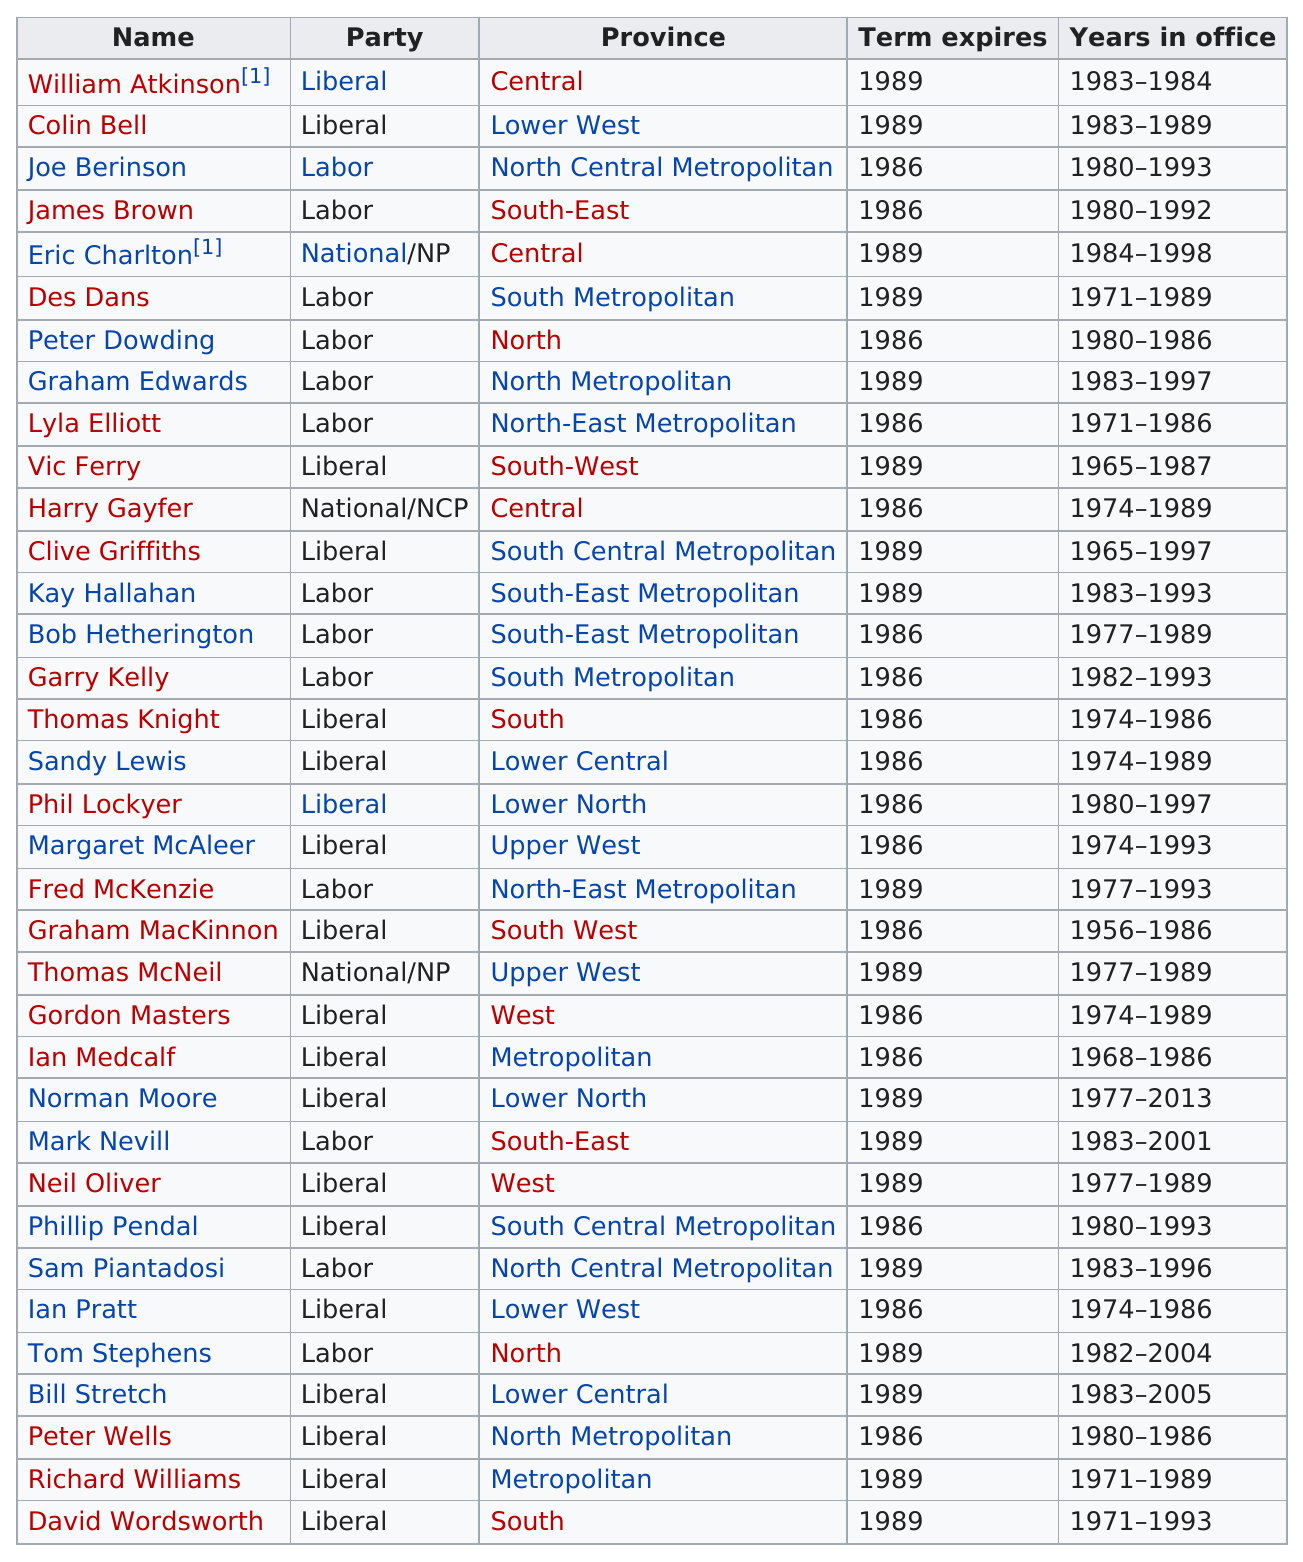Draw attention to some important aspects in this diagram. I have located the last member listed in the database whose last name starts with the letter 'p', which is Ian Pratt. There are 19 individuals in the Liberal Party. The Liberal party has the most membership. Phil Lockyer's political party was the Liberal party. William Atkinson has served the shortest term in office among all presidents. 